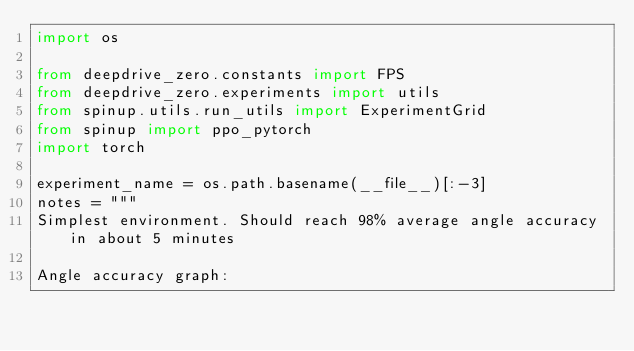Convert code to text. <code><loc_0><loc_0><loc_500><loc_500><_Python_>import os

from deepdrive_zero.constants import FPS
from deepdrive_zero.experiments import utils
from spinup.utils.run_utils import ExperimentGrid
from spinup import ppo_pytorch
import torch

experiment_name = os.path.basename(__file__)[:-3]
notes = """
Simplest environment. Should reach 98% average angle accuracy in about 5 minutes

Angle accuracy graph:</code> 